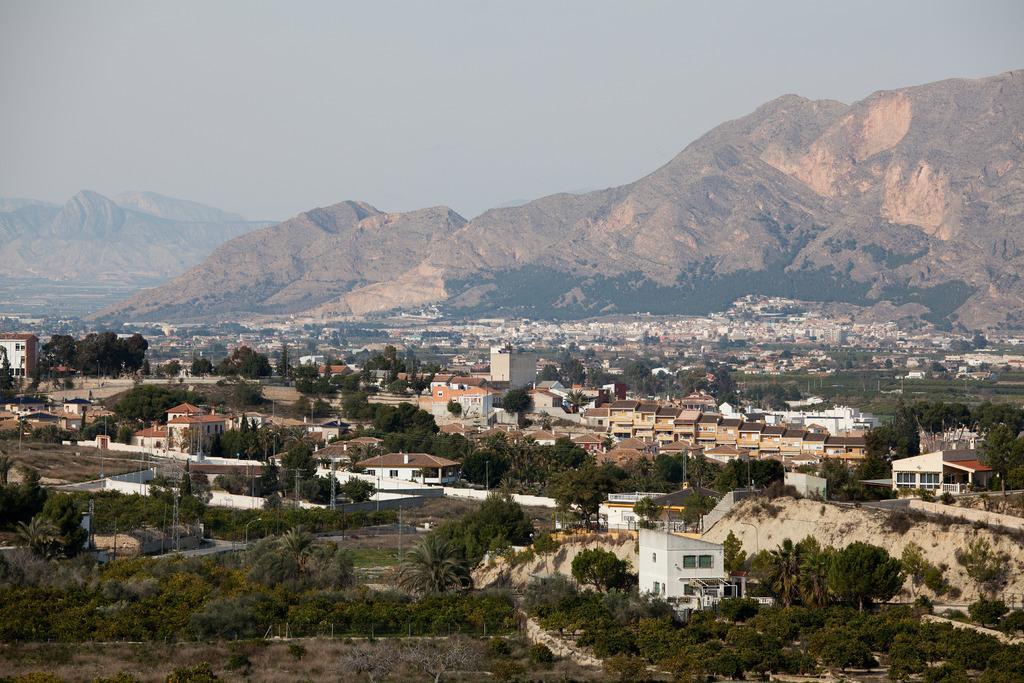How would you summarize this image in a sentence or two? In this image I can see the ground, few trees which are green and brown in color, few buildings which are white, brown and orange in color and in the background I can see few mountains and the sky. 